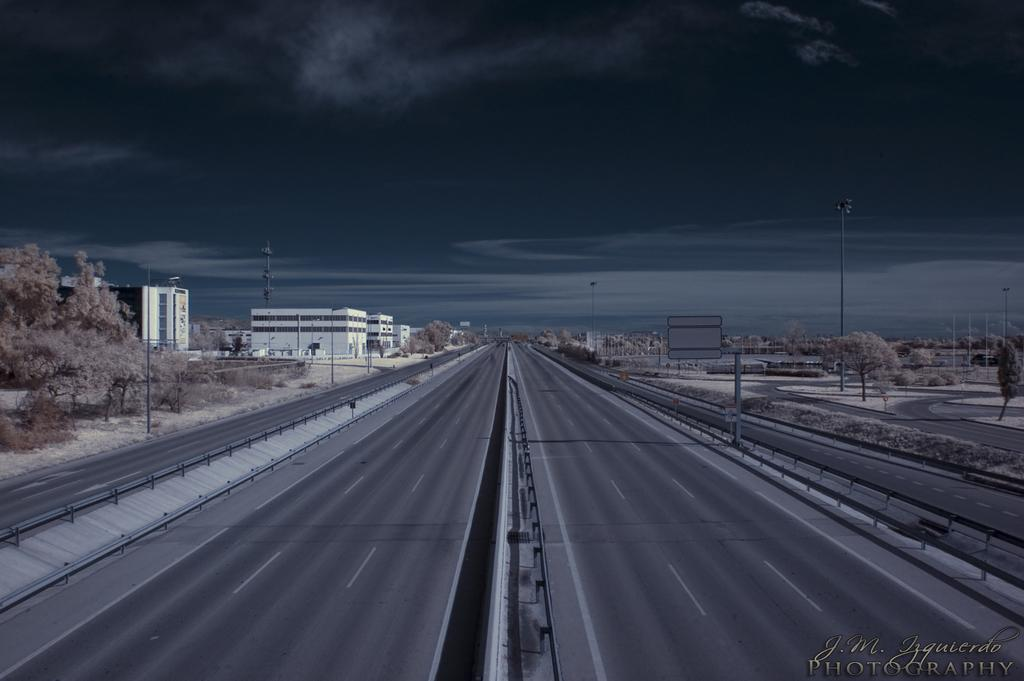What type of structures can be seen in the image? There are pathways, poles, a tower, a signboard, a group of trees, and buildings visible in the image. What type of vegetation is present in the image? There are plants and a group of trees in the image. What is the condition of the sky in the image? The sky is visible in the image, and it appears cloudy. What type of van can be seen parked near the tower in the image? There is no van present in the image. What emotion is expressed by the trees in the image? Trees do not express emotions, so this question cannot be answered. 